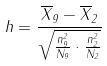<formula> <loc_0><loc_0><loc_500><loc_500>h = \frac { \overline { X } _ { 9 } - \overline { X } _ { 2 } } { \sqrt { \frac { n _ { 9 } ^ { 2 } } { N _ { 9 } } \cdot \frac { n _ { 2 } ^ { 2 } } { N _ { 2 } } } }</formula> 